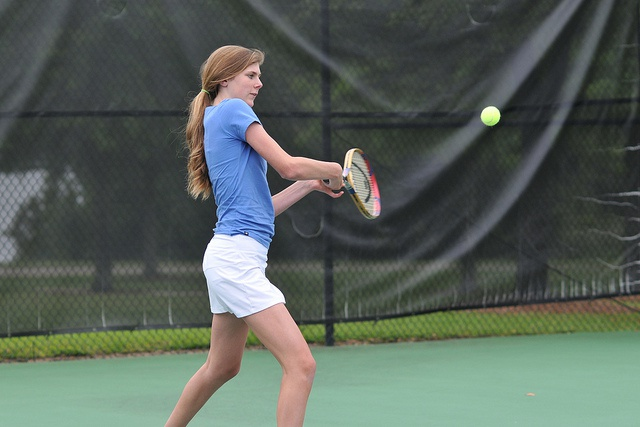Describe the objects in this image and their specific colors. I can see people in gray, lightpink, and lavender tones, tennis racket in gray, darkgray, beige, and lightpink tones, and sports ball in gray, khaki, lightyellow, and lightgreen tones in this image. 